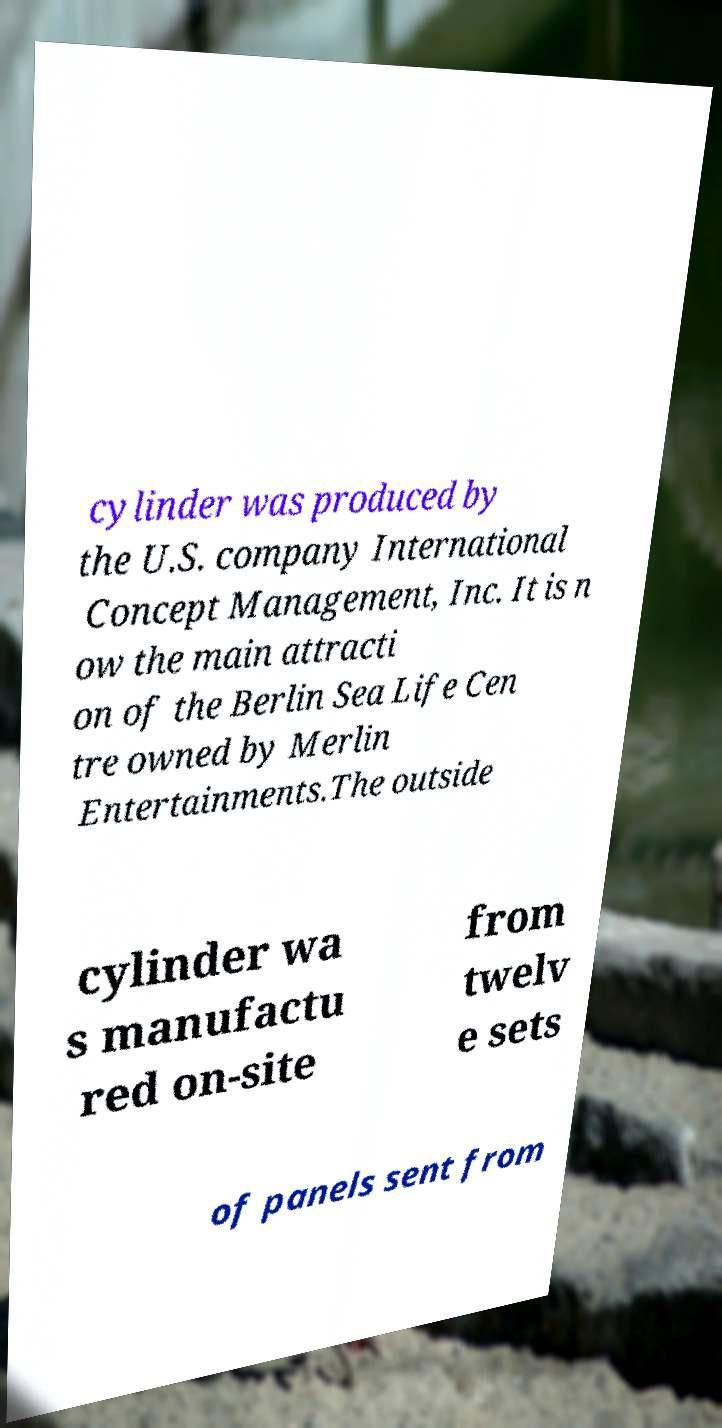For documentation purposes, I need the text within this image transcribed. Could you provide that? cylinder was produced by the U.S. company International Concept Management, Inc. It is n ow the main attracti on of the Berlin Sea Life Cen tre owned by Merlin Entertainments.The outside cylinder wa s manufactu red on-site from twelv e sets of panels sent from 